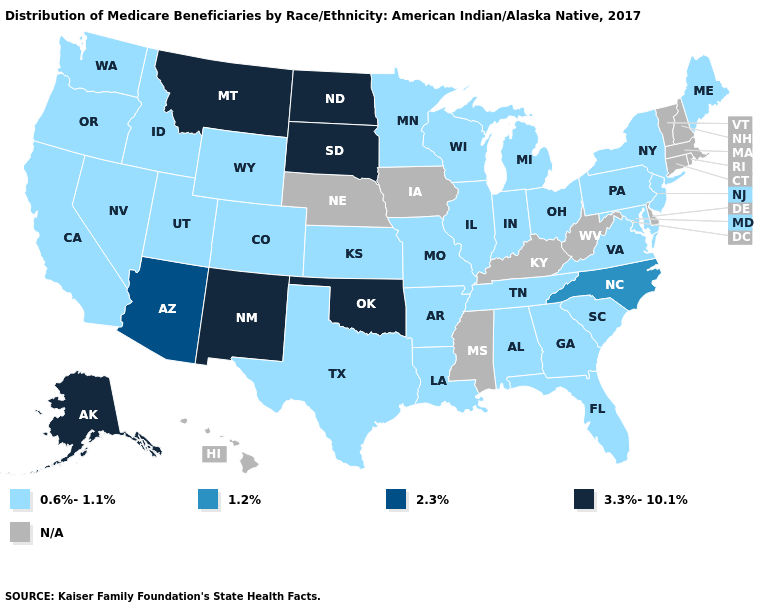Name the states that have a value in the range 3.3%-10.1%?
Keep it brief. Alaska, Montana, New Mexico, North Dakota, Oklahoma, South Dakota. Does New Jersey have the highest value in the USA?
Be succinct. No. Does the first symbol in the legend represent the smallest category?
Answer briefly. Yes. Among the states that border Idaho , does Montana have the lowest value?
Keep it brief. No. What is the value of Hawaii?
Concise answer only. N/A. What is the value of Arizona?
Concise answer only. 2.3%. What is the value of Arkansas?
Quick response, please. 0.6%-1.1%. Does Washington have the highest value in the USA?
Answer briefly. No. Does the map have missing data?
Quick response, please. Yes. Name the states that have a value in the range 3.3%-10.1%?
Short answer required. Alaska, Montana, New Mexico, North Dakota, Oklahoma, South Dakota. Which states have the highest value in the USA?
Give a very brief answer. Alaska, Montana, New Mexico, North Dakota, Oklahoma, South Dakota. Name the states that have a value in the range 0.6%-1.1%?
Write a very short answer. Alabama, Arkansas, California, Colorado, Florida, Georgia, Idaho, Illinois, Indiana, Kansas, Louisiana, Maine, Maryland, Michigan, Minnesota, Missouri, Nevada, New Jersey, New York, Ohio, Oregon, Pennsylvania, South Carolina, Tennessee, Texas, Utah, Virginia, Washington, Wisconsin, Wyoming. Which states have the lowest value in the USA?
Write a very short answer. Alabama, Arkansas, California, Colorado, Florida, Georgia, Idaho, Illinois, Indiana, Kansas, Louisiana, Maine, Maryland, Michigan, Minnesota, Missouri, Nevada, New Jersey, New York, Ohio, Oregon, Pennsylvania, South Carolina, Tennessee, Texas, Utah, Virginia, Washington, Wisconsin, Wyoming. What is the lowest value in the MidWest?
Quick response, please. 0.6%-1.1%. 